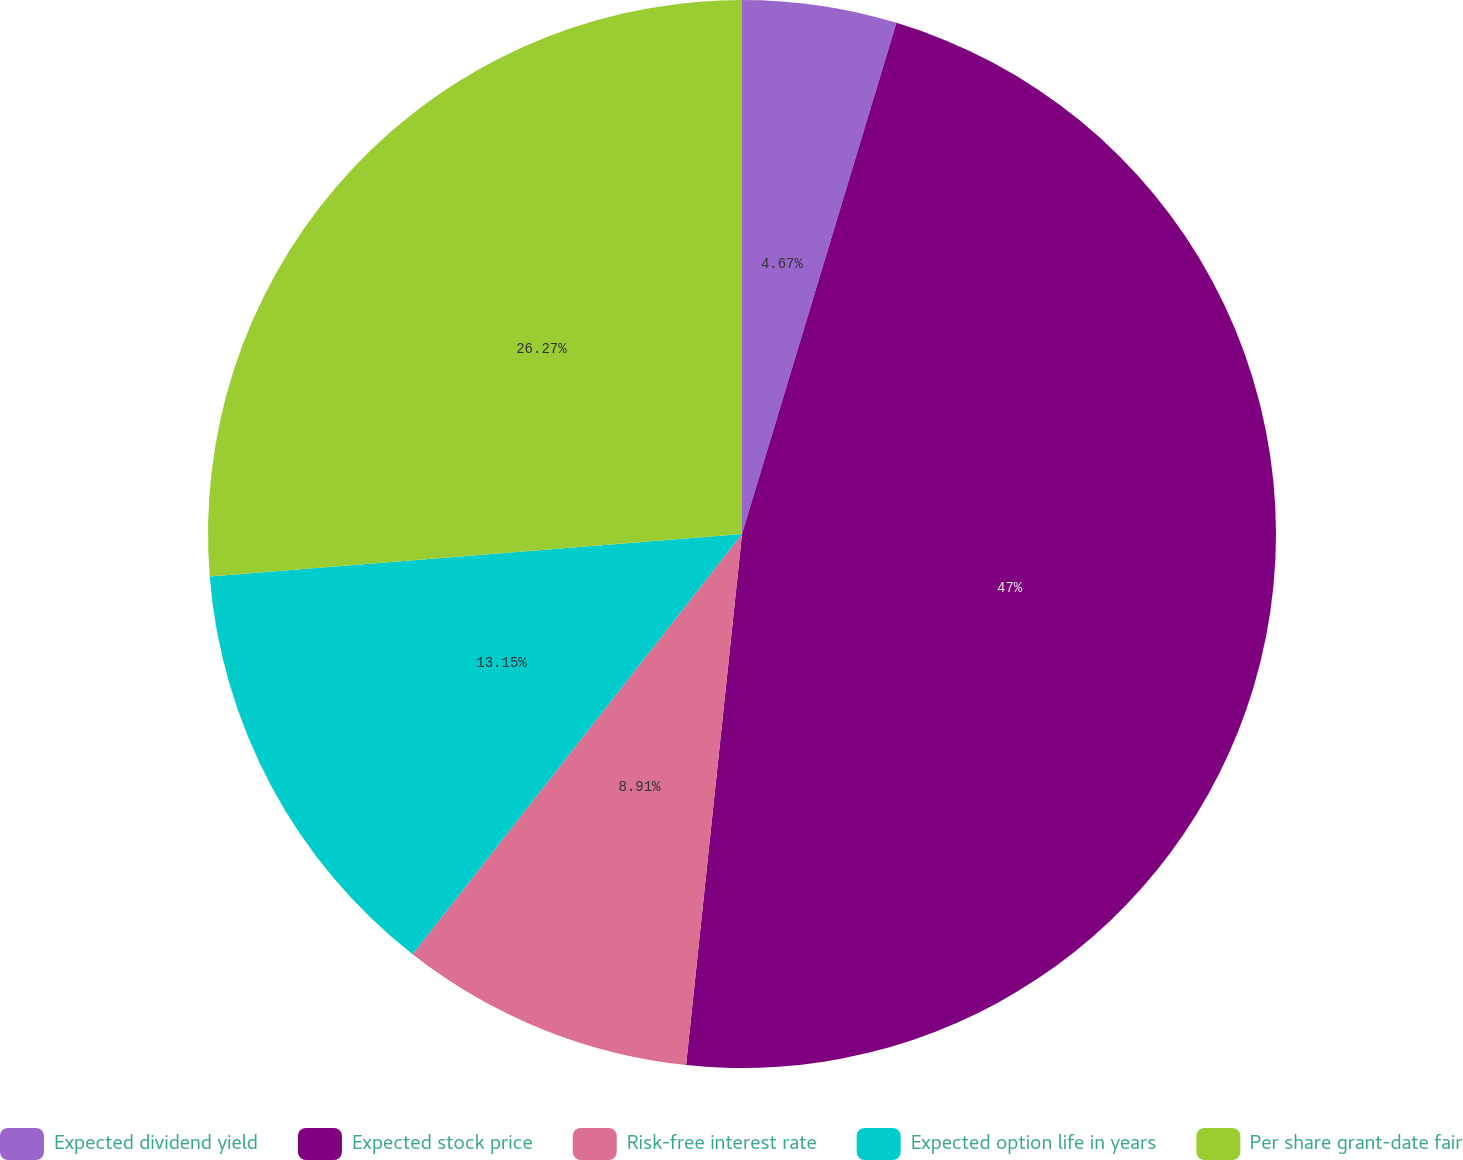Convert chart to OTSL. <chart><loc_0><loc_0><loc_500><loc_500><pie_chart><fcel>Expected dividend yield<fcel>Expected stock price<fcel>Risk-free interest rate<fcel>Expected option life in years<fcel>Per share grant-date fair<nl><fcel>4.67%<fcel>47.0%<fcel>8.91%<fcel>13.15%<fcel>26.27%<nl></chart> 